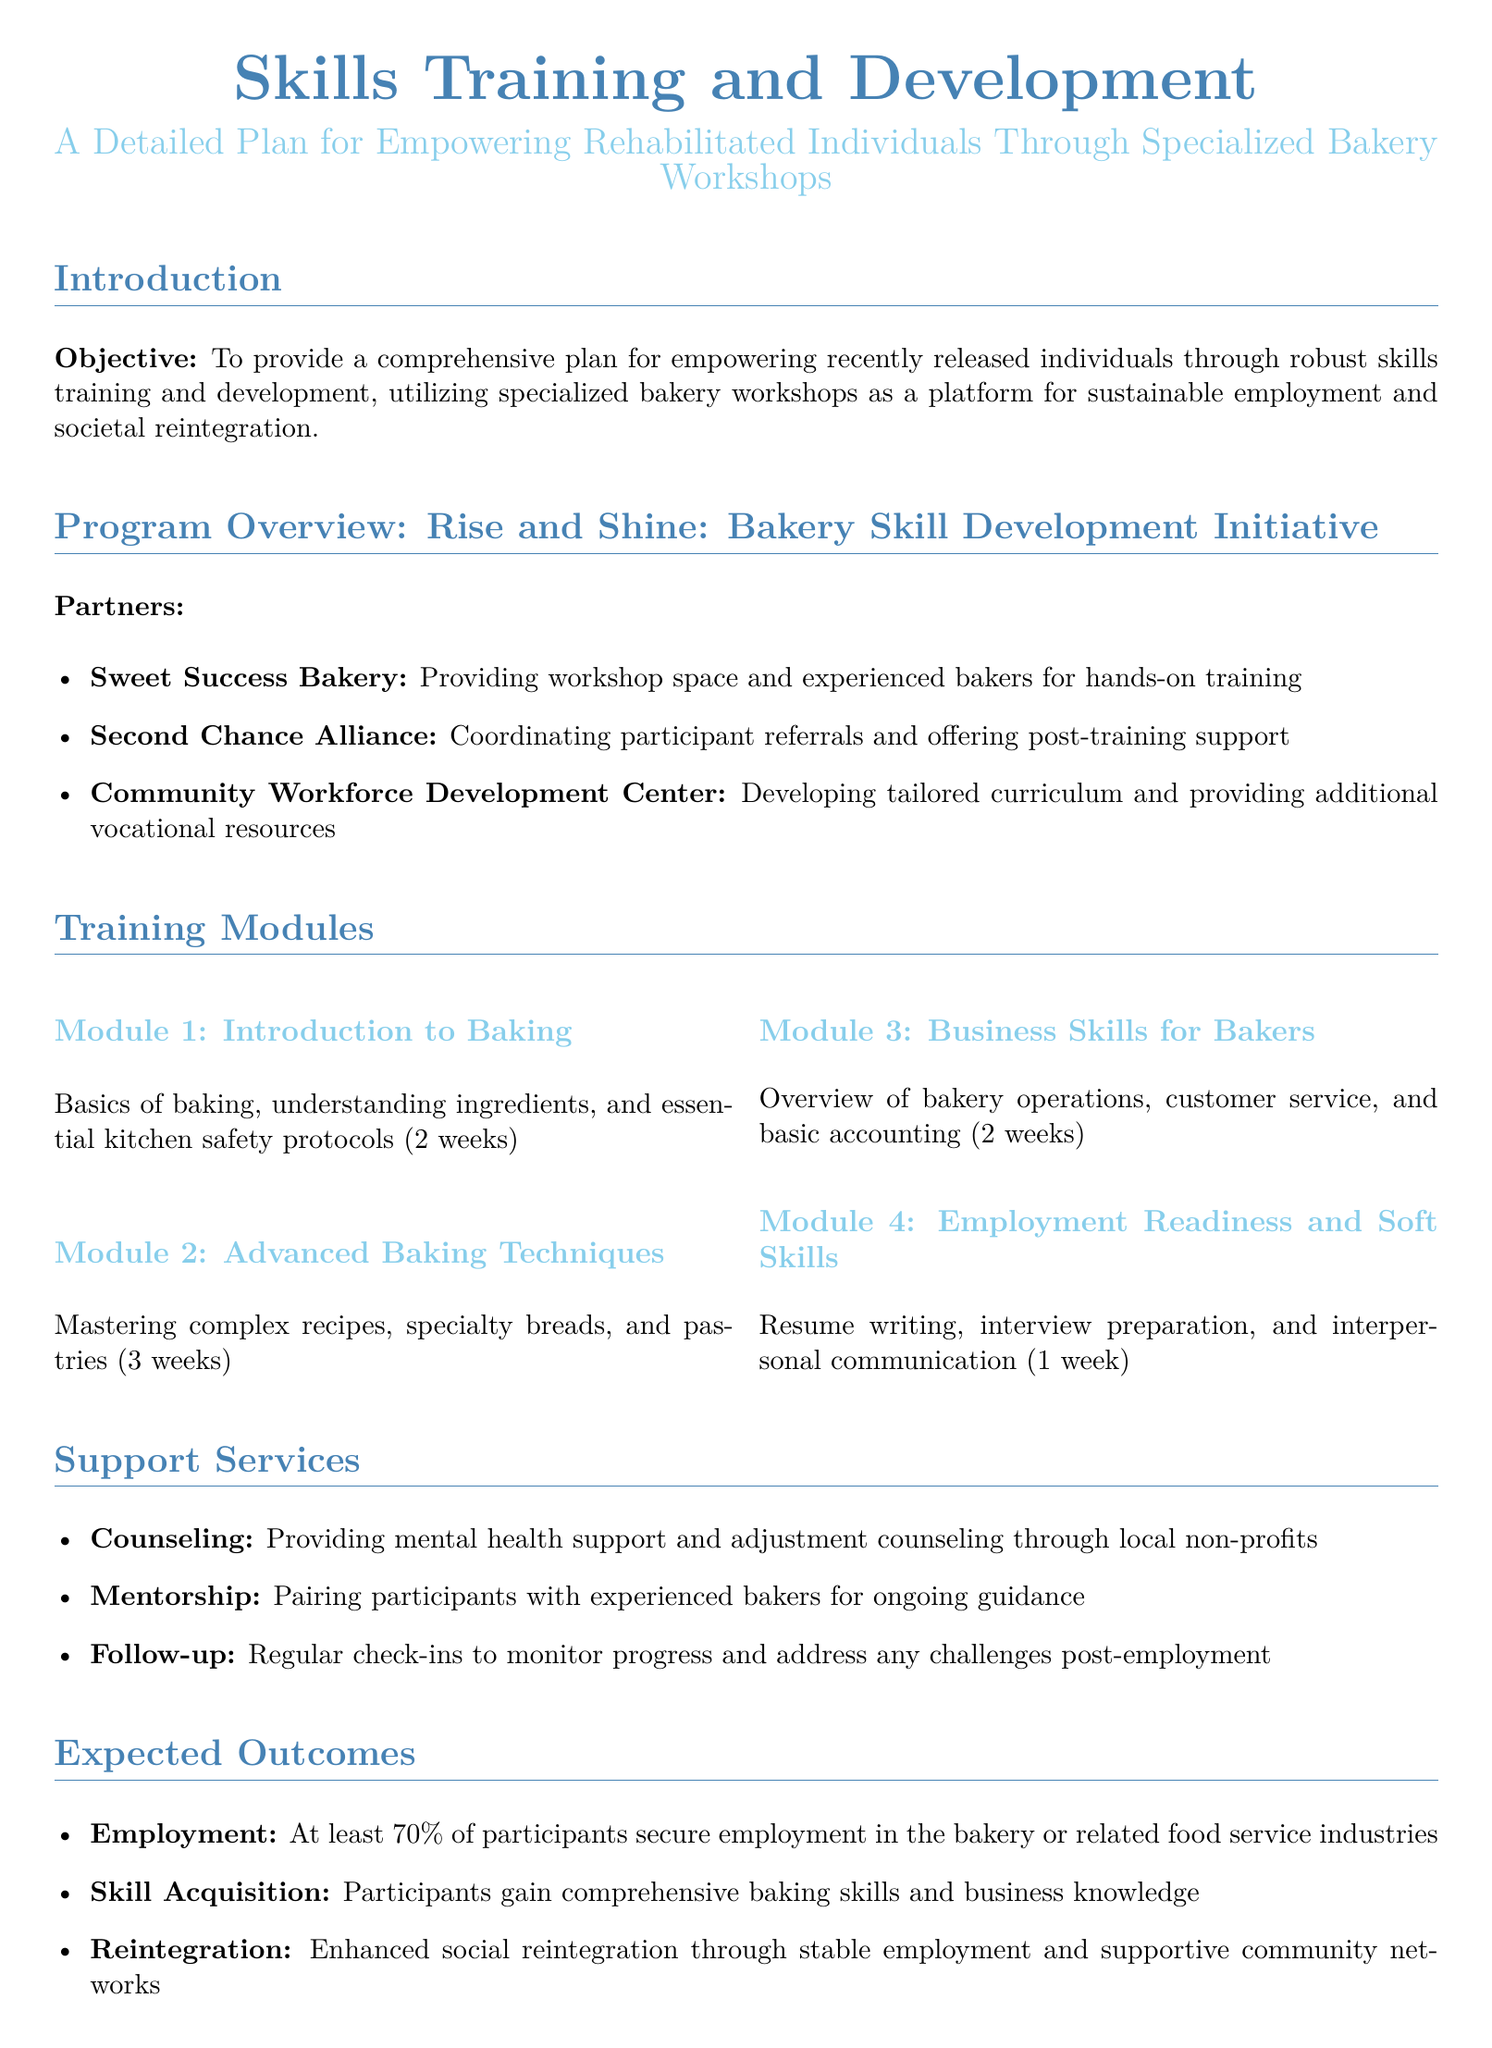What is the objective of the proposal? The objective is to provide a comprehensive plan for empowering recently released individuals through robust skills training and development.
Answer: To provide a comprehensive plan for empowering recently released individuals through robust skills training and development Who are the partners involved in the program? The partners listed include Sweet Success Bakery, Second Chance Alliance, and Community Workforce Development Center.
Answer: Sweet Success Bakery, Second Chance Alliance, Community Workforce Development Center How long is the Advanced Baking Techniques module? The duration of the Advanced Baking Techniques module is specified in the document.
Answer: 3 weeks What type of support is provided through the program? The document lists counseling, mentorship, and follow-up as support services provided.
Answer: Counseling, Mentorship, Follow-up What is the expected employment rate for participants? The proposal outlines an expected outcome regarding employment, stated as a percentage.
Answer: At least 70% How will the program evaluate its success? The evaluation plan employs metrics such as job placement rate, participant satisfaction, and retention rate.
Answer: Job placement rate, participant satisfaction, retention rate What is the duration of the Employment Readiness and Soft Skills module? This specific module's duration is mentioned in the training modules section of the proposal.
Answer: 1 week What are the expected outcomes concerning skill acquisition? The expected outcome regarding skill acquisition is detailed in the document and specifies what participants gain.
Answer: Participants gain comprehensive baking skills and business knowledge What types of counseling are offered? The document notes the type of counseling services provided through local non-profits as part of support.
Answer: Mental health support and adjustment counseling 